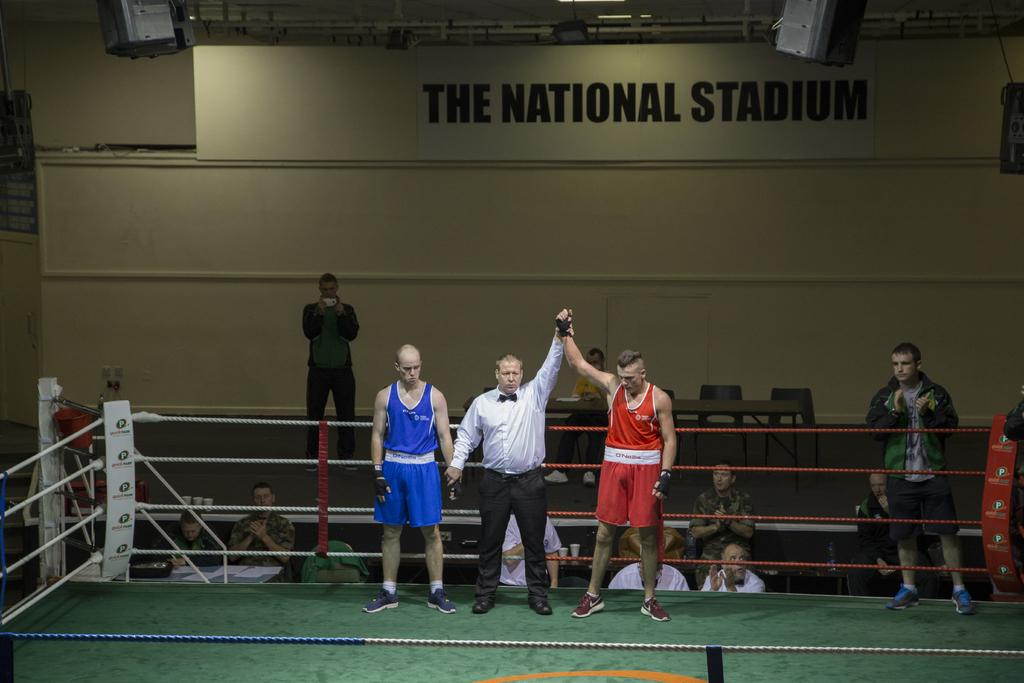<image>
Relay a brief, clear account of the picture shown. A boxing match in which the man in red defeated the man in blue in front of a sign reading The National Stadium. 